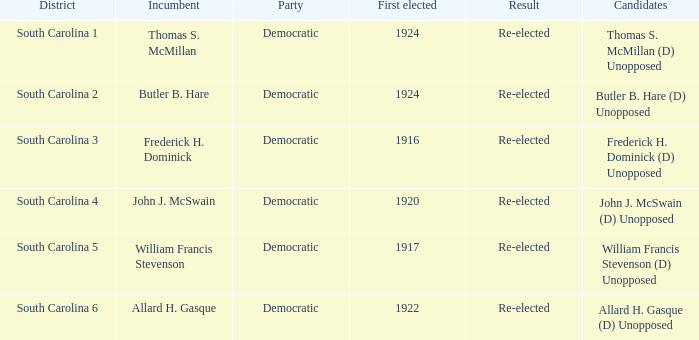Would you mind parsing the complete table? {'header': ['District', 'Incumbent', 'Party', 'First elected', 'Result', 'Candidates'], 'rows': [['South Carolina 1', 'Thomas S. McMillan', 'Democratic', '1924', 'Re-elected', 'Thomas S. McMillan (D) Unopposed'], ['South Carolina 2', 'Butler B. Hare', 'Democratic', '1924', 'Re-elected', 'Butler B. Hare (D) Unopposed'], ['South Carolina 3', 'Frederick H. Dominick', 'Democratic', '1916', 'Re-elected', 'Frederick H. Dominick (D) Unopposed'], ['South Carolina 4', 'John J. McSwain', 'Democratic', '1920', 'Re-elected', 'John J. McSwain (D) Unopposed'], ['South Carolina 5', 'William Francis Stevenson', 'Democratic', '1917', 'Re-elected', 'William Francis Stevenson (D) Unopposed'], ['South Carolina 6', 'Allard H. Gasque', 'Democratic', '1922', 'Re-elected', 'Allard H. Gasque (D) Unopposed']]} What is the result for thomas s. mcmillan? Re-elected. 